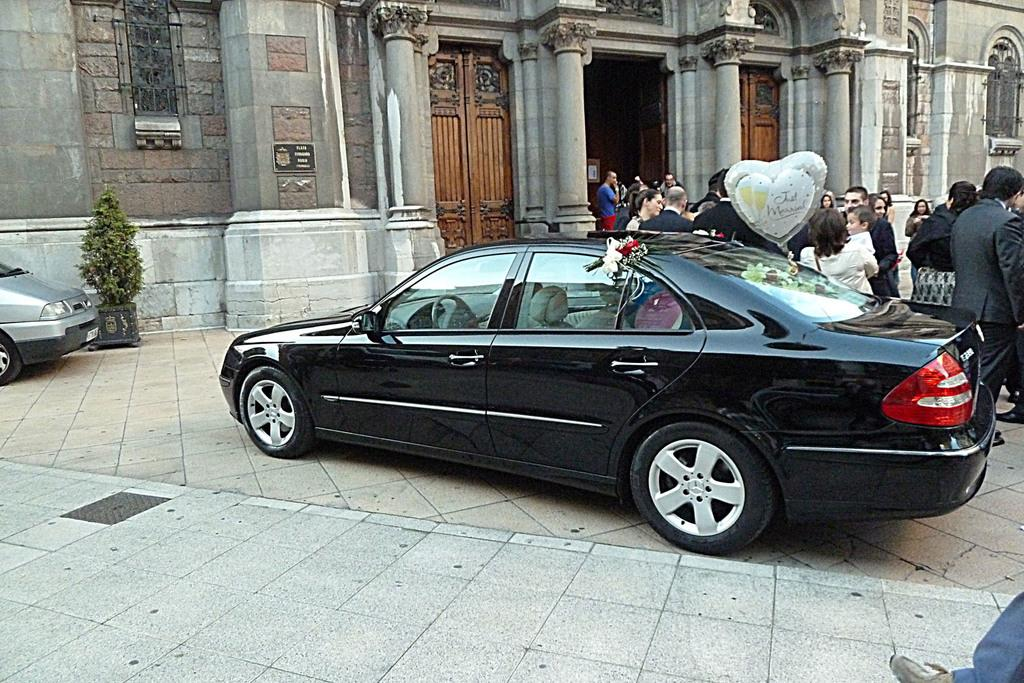What types of objects can be seen in the image? There are vehicles, a balloon, and a plant in the image. Are there any living beings in the image? Yes, there is a group of people standing in the image. What else can be seen in the background of the image? There is a building in the image. What type of pickle is being used as a decoration on the dress in the image? There is no pickle or dress present in the image. Can you describe the volcano erupting in the background of the image? There is no volcano present in the image. 